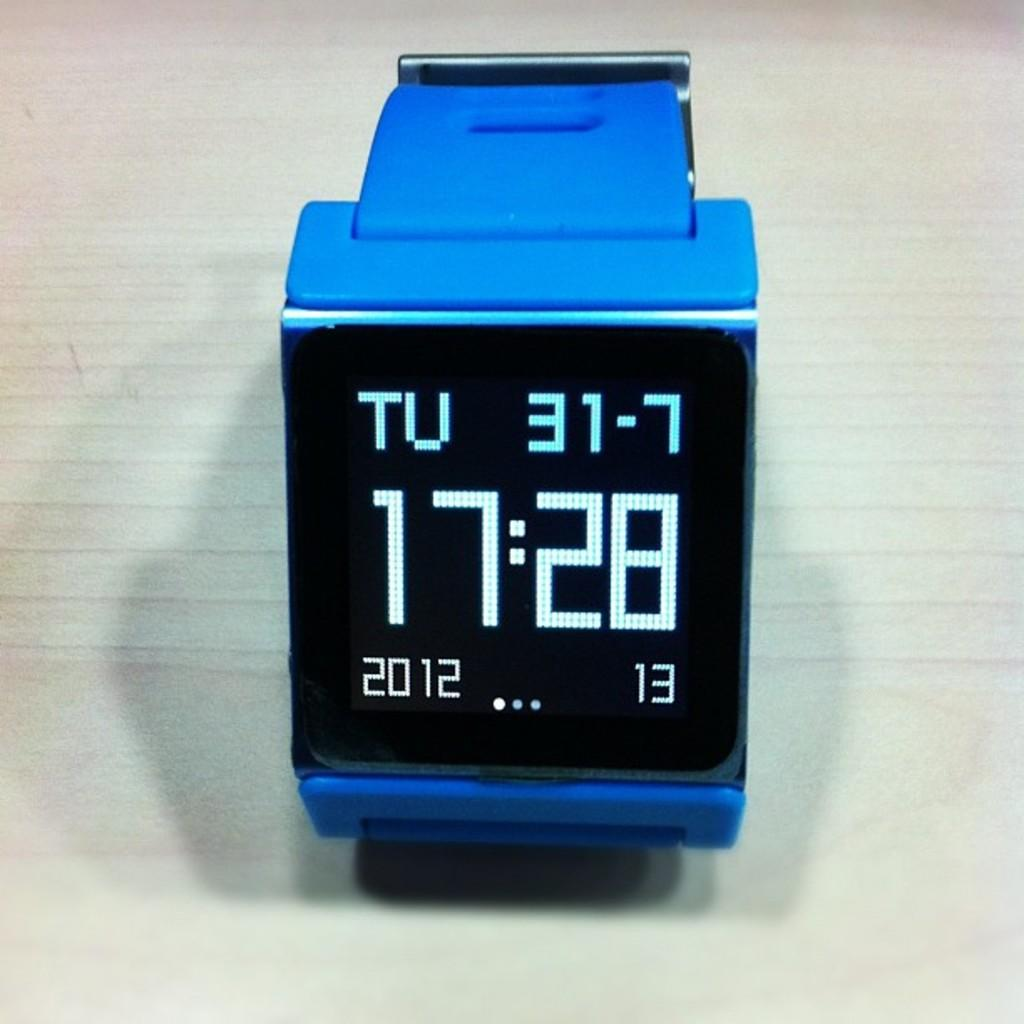Provide a one-sentence caption for the provided image. a blue watch with a black face stating the time as 17:28. 